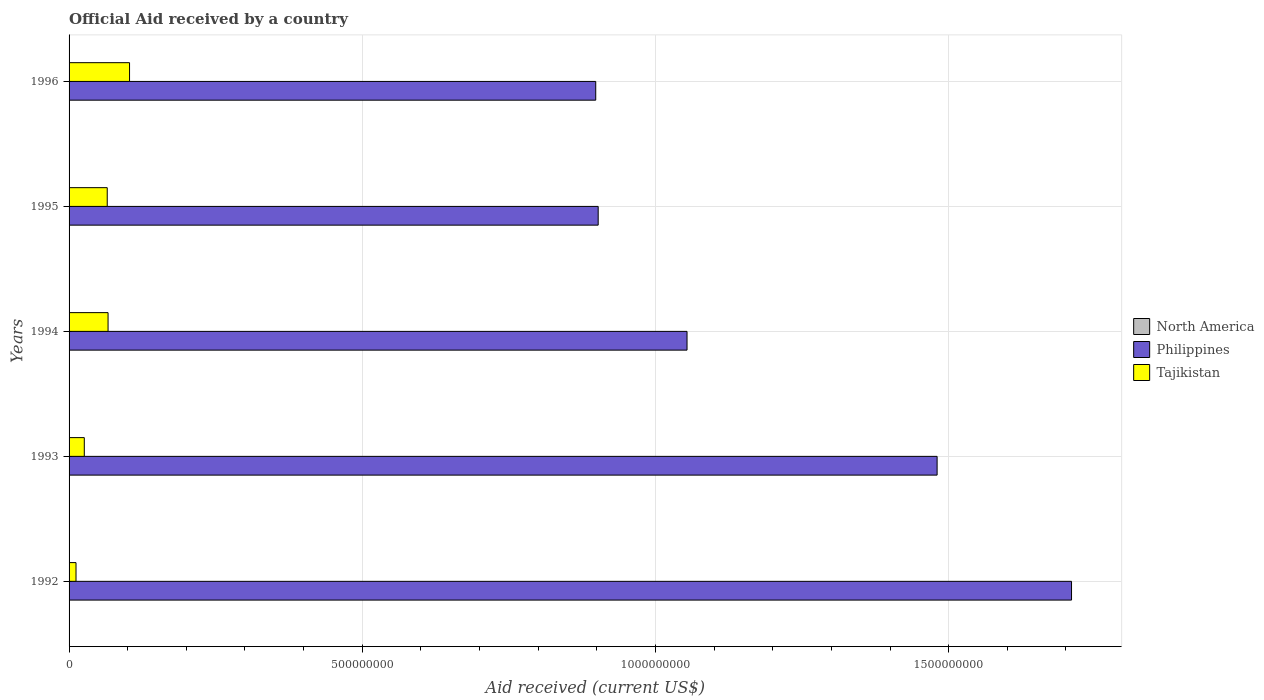How many different coloured bars are there?
Provide a short and direct response. 2. How many groups of bars are there?
Ensure brevity in your answer.  5. Are the number of bars on each tick of the Y-axis equal?
Provide a short and direct response. Yes. How many bars are there on the 3rd tick from the top?
Provide a succinct answer. 2. What is the label of the 5th group of bars from the top?
Make the answer very short. 1992. What is the net official aid received in Tajikistan in 1992?
Make the answer very short. 1.18e+07. Across all years, what is the maximum net official aid received in Philippines?
Your answer should be compact. 1.71e+09. Across all years, what is the minimum net official aid received in Tajikistan?
Keep it short and to the point. 1.18e+07. What is the difference between the net official aid received in Philippines in 1993 and that in 1994?
Your answer should be very brief. 4.26e+08. What is the difference between the net official aid received in Tajikistan in 1992 and the net official aid received in Philippines in 1994?
Offer a terse response. -1.04e+09. What is the average net official aid received in Tajikistan per year?
Ensure brevity in your answer.  5.45e+07. In the year 1995, what is the difference between the net official aid received in Tajikistan and net official aid received in Philippines?
Ensure brevity in your answer.  -8.37e+08. What is the ratio of the net official aid received in Philippines in 1992 to that in 1996?
Your answer should be very brief. 1.9. Is the net official aid received in Tajikistan in 1992 less than that in 1996?
Keep it short and to the point. Yes. Is the difference between the net official aid received in Tajikistan in 1993 and 1996 greater than the difference between the net official aid received in Philippines in 1993 and 1996?
Offer a very short reply. No. What is the difference between the highest and the second highest net official aid received in Tajikistan?
Keep it short and to the point. 3.66e+07. What is the difference between the highest and the lowest net official aid received in Philippines?
Offer a very short reply. 8.11e+08. Is the sum of the net official aid received in Philippines in 1993 and 1994 greater than the maximum net official aid received in Tajikistan across all years?
Keep it short and to the point. Yes. How many bars are there?
Your response must be concise. 10. How many years are there in the graph?
Give a very brief answer. 5. What is the difference between two consecutive major ticks on the X-axis?
Keep it short and to the point. 5.00e+08. Are the values on the major ticks of X-axis written in scientific E-notation?
Provide a succinct answer. No. Does the graph contain any zero values?
Your answer should be compact. Yes. Where does the legend appear in the graph?
Keep it short and to the point. Center right. How many legend labels are there?
Provide a succinct answer. 3. What is the title of the graph?
Provide a succinct answer. Official Aid received by a country. Does "Upper middle income" appear as one of the legend labels in the graph?
Make the answer very short. No. What is the label or title of the X-axis?
Make the answer very short. Aid received (current US$). What is the label or title of the Y-axis?
Provide a short and direct response. Years. What is the Aid received (current US$) of North America in 1992?
Ensure brevity in your answer.  0. What is the Aid received (current US$) of Philippines in 1992?
Ensure brevity in your answer.  1.71e+09. What is the Aid received (current US$) of Tajikistan in 1992?
Offer a very short reply. 1.18e+07. What is the Aid received (current US$) in Philippines in 1993?
Keep it short and to the point. 1.48e+09. What is the Aid received (current US$) of Tajikistan in 1993?
Offer a terse response. 2.60e+07. What is the Aid received (current US$) in North America in 1994?
Your answer should be very brief. 0. What is the Aid received (current US$) of Philippines in 1994?
Your response must be concise. 1.05e+09. What is the Aid received (current US$) of Tajikistan in 1994?
Ensure brevity in your answer.  6.65e+07. What is the Aid received (current US$) of Philippines in 1995?
Keep it short and to the point. 9.02e+08. What is the Aid received (current US$) of Tajikistan in 1995?
Make the answer very short. 6.51e+07. What is the Aid received (current US$) in Philippines in 1996?
Offer a very short reply. 8.98e+08. What is the Aid received (current US$) of Tajikistan in 1996?
Provide a succinct answer. 1.03e+08. Across all years, what is the maximum Aid received (current US$) in Philippines?
Provide a succinct answer. 1.71e+09. Across all years, what is the maximum Aid received (current US$) of Tajikistan?
Your answer should be very brief. 1.03e+08. Across all years, what is the minimum Aid received (current US$) in Philippines?
Your answer should be very brief. 8.98e+08. Across all years, what is the minimum Aid received (current US$) in Tajikistan?
Offer a terse response. 1.18e+07. What is the total Aid received (current US$) of Philippines in the graph?
Provide a succinct answer. 6.04e+09. What is the total Aid received (current US$) in Tajikistan in the graph?
Provide a short and direct response. 2.73e+08. What is the difference between the Aid received (current US$) in Philippines in 1992 and that in 1993?
Provide a succinct answer. 2.29e+08. What is the difference between the Aid received (current US$) in Tajikistan in 1992 and that in 1993?
Provide a short and direct response. -1.41e+07. What is the difference between the Aid received (current US$) of Philippines in 1992 and that in 1994?
Make the answer very short. 6.56e+08. What is the difference between the Aid received (current US$) of Tajikistan in 1992 and that in 1994?
Keep it short and to the point. -5.47e+07. What is the difference between the Aid received (current US$) of Philippines in 1992 and that in 1995?
Ensure brevity in your answer.  8.07e+08. What is the difference between the Aid received (current US$) of Tajikistan in 1992 and that in 1995?
Make the answer very short. -5.32e+07. What is the difference between the Aid received (current US$) in Philippines in 1992 and that in 1996?
Keep it short and to the point. 8.11e+08. What is the difference between the Aid received (current US$) of Tajikistan in 1992 and that in 1996?
Provide a succinct answer. -9.13e+07. What is the difference between the Aid received (current US$) of Philippines in 1993 and that in 1994?
Your response must be concise. 4.26e+08. What is the difference between the Aid received (current US$) in Tajikistan in 1993 and that in 1994?
Your response must be concise. -4.05e+07. What is the difference between the Aid received (current US$) in Philippines in 1993 and that in 1995?
Provide a succinct answer. 5.78e+08. What is the difference between the Aid received (current US$) in Tajikistan in 1993 and that in 1995?
Make the answer very short. -3.91e+07. What is the difference between the Aid received (current US$) in Philippines in 1993 and that in 1996?
Offer a terse response. 5.82e+08. What is the difference between the Aid received (current US$) of Tajikistan in 1993 and that in 1996?
Provide a succinct answer. -7.72e+07. What is the difference between the Aid received (current US$) of Philippines in 1994 and that in 1995?
Your answer should be very brief. 1.52e+08. What is the difference between the Aid received (current US$) in Tajikistan in 1994 and that in 1995?
Keep it short and to the point. 1.42e+06. What is the difference between the Aid received (current US$) in Philippines in 1994 and that in 1996?
Provide a succinct answer. 1.56e+08. What is the difference between the Aid received (current US$) of Tajikistan in 1994 and that in 1996?
Give a very brief answer. -3.66e+07. What is the difference between the Aid received (current US$) of Philippines in 1995 and that in 1996?
Offer a terse response. 4.18e+06. What is the difference between the Aid received (current US$) of Tajikistan in 1995 and that in 1996?
Give a very brief answer. -3.81e+07. What is the difference between the Aid received (current US$) of Philippines in 1992 and the Aid received (current US$) of Tajikistan in 1993?
Provide a succinct answer. 1.68e+09. What is the difference between the Aid received (current US$) of Philippines in 1992 and the Aid received (current US$) of Tajikistan in 1994?
Offer a terse response. 1.64e+09. What is the difference between the Aid received (current US$) in Philippines in 1992 and the Aid received (current US$) in Tajikistan in 1995?
Ensure brevity in your answer.  1.64e+09. What is the difference between the Aid received (current US$) of Philippines in 1992 and the Aid received (current US$) of Tajikistan in 1996?
Your answer should be very brief. 1.61e+09. What is the difference between the Aid received (current US$) in Philippines in 1993 and the Aid received (current US$) in Tajikistan in 1994?
Ensure brevity in your answer.  1.41e+09. What is the difference between the Aid received (current US$) of Philippines in 1993 and the Aid received (current US$) of Tajikistan in 1995?
Your answer should be compact. 1.42e+09. What is the difference between the Aid received (current US$) in Philippines in 1993 and the Aid received (current US$) in Tajikistan in 1996?
Ensure brevity in your answer.  1.38e+09. What is the difference between the Aid received (current US$) of Philippines in 1994 and the Aid received (current US$) of Tajikistan in 1995?
Keep it short and to the point. 9.89e+08. What is the difference between the Aid received (current US$) of Philippines in 1994 and the Aid received (current US$) of Tajikistan in 1996?
Offer a terse response. 9.51e+08. What is the difference between the Aid received (current US$) of Philippines in 1995 and the Aid received (current US$) of Tajikistan in 1996?
Keep it short and to the point. 7.99e+08. What is the average Aid received (current US$) in Philippines per year?
Your answer should be compact. 1.21e+09. What is the average Aid received (current US$) in Tajikistan per year?
Offer a very short reply. 5.45e+07. In the year 1992, what is the difference between the Aid received (current US$) of Philippines and Aid received (current US$) of Tajikistan?
Provide a succinct answer. 1.70e+09. In the year 1993, what is the difference between the Aid received (current US$) of Philippines and Aid received (current US$) of Tajikistan?
Ensure brevity in your answer.  1.45e+09. In the year 1994, what is the difference between the Aid received (current US$) in Philippines and Aid received (current US$) in Tajikistan?
Offer a terse response. 9.87e+08. In the year 1995, what is the difference between the Aid received (current US$) in Philippines and Aid received (current US$) in Tajikistan?
Ensure brevity in your answer.  8.37e+08. In the year 1996, what is the difference between the Aid received (current US$) in Philippines and Aid received (current US$) in Tajikistan?
Offer a terse response. 7.95e+08. What is the ratio of the Aid received (current US$) of Philippines in 1992 to that in 1993?
Give a very brief answer. 1.15. What is the ratio of the Aid received (current US$) in Tajikistan in 1992 to that in 1993?
Your answer should be very brief. 0.46. What is the ratio of the Aid received (current US$) in Philippines in 1992 to that in 1994?
Your response must be concise. 1.62. What is the ratio of the Aid received (current US$) in Tajikistan in 1992 to that in 1994?
Keep it short and to the point. 0.18. What is the ratio of the Aid received (current US$) of Philippines in 1992 to that in 1995?
Offer a terse response. 1.89. What is the ratio of the Aid received (current US$) in Tajikistan in 1992 to that in 1995?
Offer a terse response. 0.18. What is the ratio of the Aid received (current US$) of Philippines in 1992 to that in 1996?
Keep it short and to the point. 1.9. What is the ratio of the Aid received (current US$) of Tajikistan in 1992 to that in 1996?
Give a very brief answer. 0.11. What is the ratio of the Aid received (current US$) in Philippines in 1993 to that in 1994?
Provide a succinct answer. 1.4. What is the ratio of the Aid received (current US$) in Tajikistan in 1993 to that in 1994?
Your response must be concise. 0.39. What is the ratio of the Aid received (current US$) of Philippines in 1993 to that in 1995?
Provide a short and direct response. 1.64. What is the ratio of the Aid received (current US$) of Tajikistan in 1993 to that in 1995?
Make the answer very short. 0.4. What is the ratio of the Aid received (current US$) of Philippines in 1993 to that in 1996?
Give a very brief answer. 1.65. What is the ratio of the Aid received (current US$) of Tajikistan in 1993 to that in 1996?
Make the answer very short. 0.25. What is the ratio of the Aid received (current US$) in Philippines in 1994 to that in 1995?
Offer a very short reply. 1.17. What is the ratio of the Aid received (current US$) of Tajikistan in 1994 to that in 1995?
Make the answer very short. 1.02. What is the ratio of the Aid received (current US$) of Philippines in 1994 to that in 1996?
Keep it short and to the point. 1.17. What is the ratio of the Aid received (current US$) of Tajikistan in 1994 to that in 1996?
Your answer should be very brief. 0.64. What is the ratio of the Aid received (current US$) of Tajikistan in 1995 to that in 1996?
Provide a succinct answer. 0.63. What is the difference between the highest and the second highest Aid received (current US$) in Philippines?
Provide a succinct answer. 2.29e+08. What is the difference between the highest and the second highest Aid received (current US$) in Tajikistan?
Provide a short and direct response. 3.66e+07. What is the difference between the highest and the lowest Aid received (current US$) of Philippines?
Your answer should be very brief. 8.11e+08. What is the difference between the highest and the lowest Aid received (current US$) of Tajikistan?
Ensure brevity in your answer.  9.13e+07. 